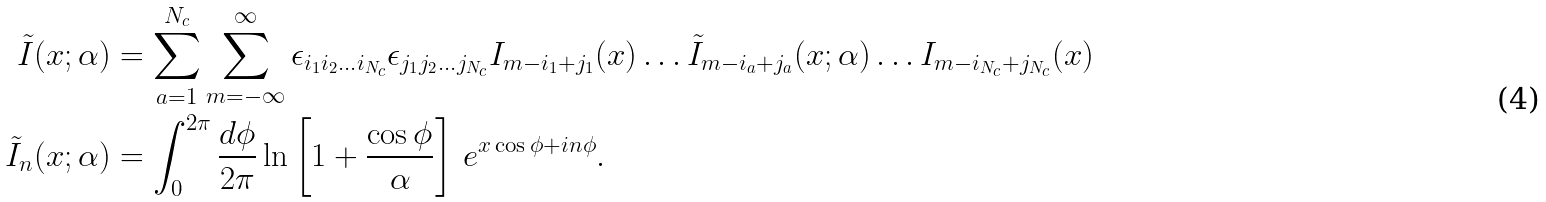Convert formula to latex. <formula><loc_0><loc_0><loc_500><loc_500>\tilde { I } ( x ; \alpha ) & = \sum _ { a = 1 } ^ { N _ { c } } \sum _ { m = - \infty } ^ { \infty } \epsilon _ { i _ { 1 } i _ { 2 } \dots i _ { N _ { c } } } \epsilon _ { j _ { 1 } j _ { 2 } \dots j _ { N _ { c } } } I _ { m - i _ { 1 } + j _ { 1 } } ( x ) \dots \tilde { I } _ { m - i _ { a } + j _ { a } } ( x ; \alpha ) \dots I _ { m - i _ { N _ { c } } + j _ { N _ { c } } } ( x ) \\ \tilde { I } _ { n } ( x ; \alpha ) & = \int _ { 0 } ^ { 2 \pi } \frac { d \phi } { 2 \pi } \ln \left [ 1 + \frac { \cos \phi } { \alpha } \right ] \, e ^ { x \cos \phi + i n \phi } .</formula> 